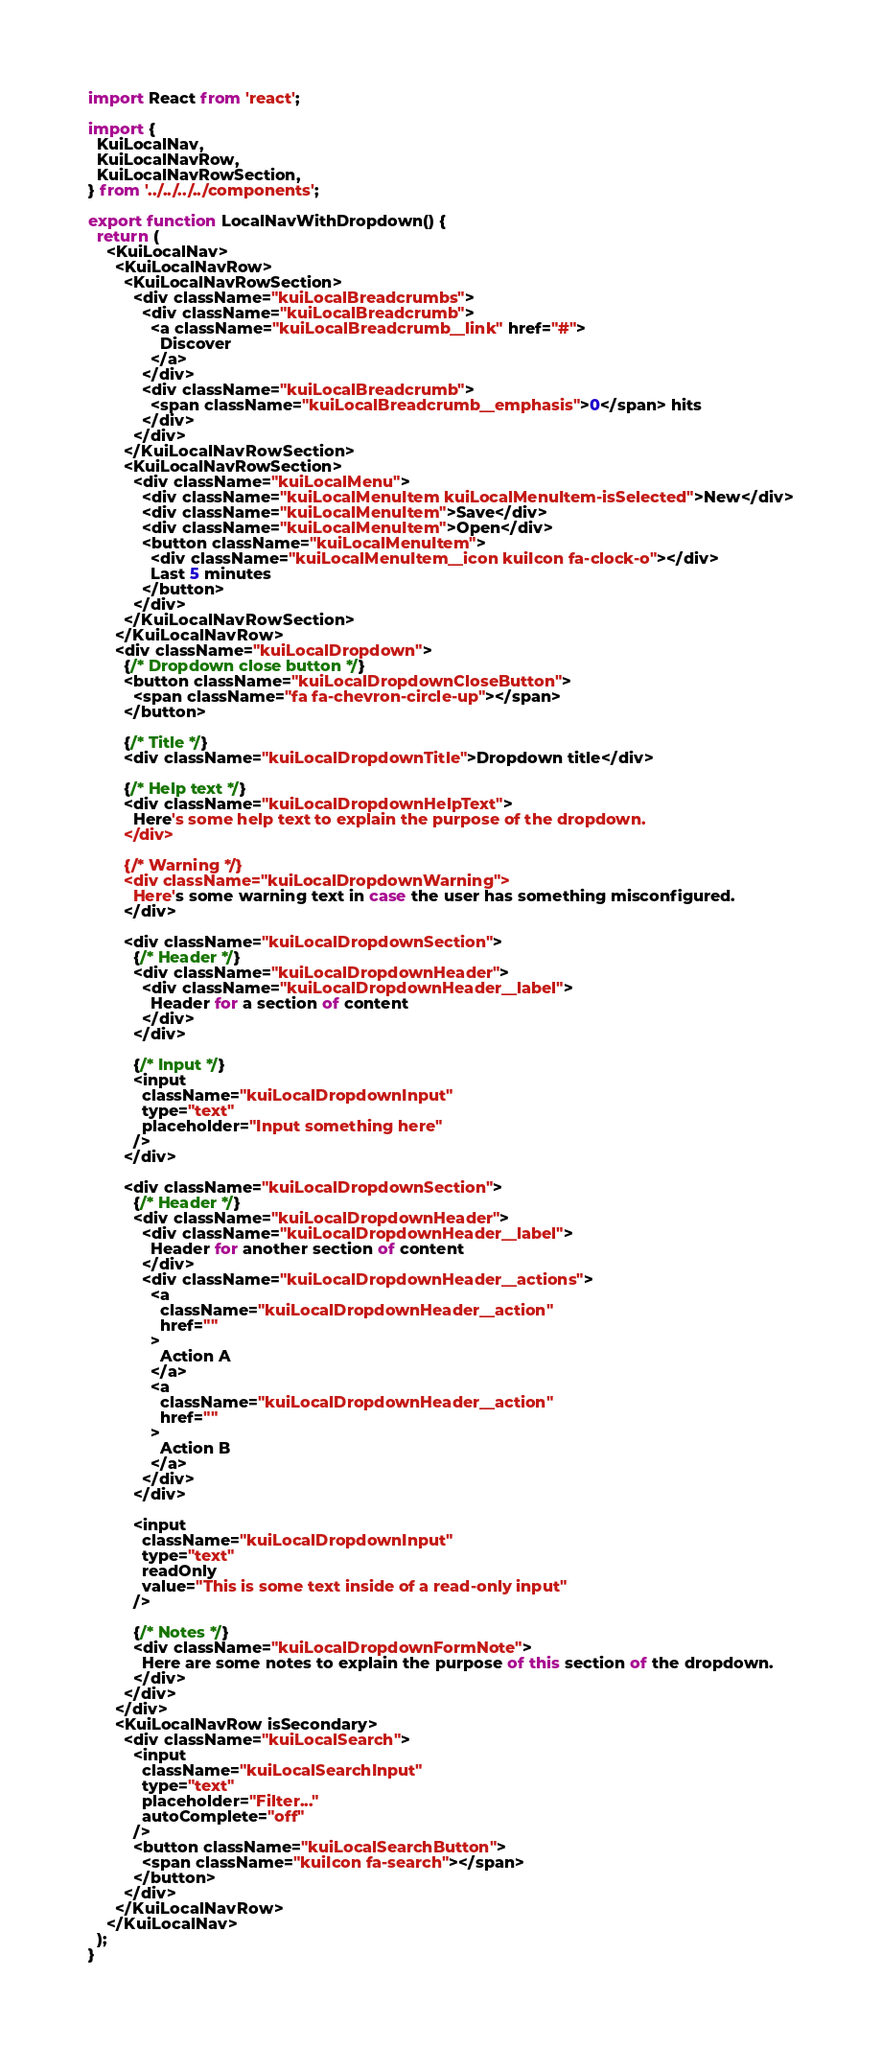Convert code to text. <code><loc_0><loc_0><loc_500><loc_500><_JavaScript_>import React from 'react';

import {
  KuiLocalNav,
  KuiLocalNavRow,
  KuiLocalNavRowSection,
} from '../../../../components';

export function LocalNavWithDropdown() {
  return (
    <KuiLocalNav>
      <KuiLocalNavRow>
        <KuiLocalNavRowSection>
          <div className="kuiLocalBreadcrumbs">
            <div className="kuiLocalBreadcrumb">
              <a className="kuiLocalBreadcrumb__link" href="#">
                Discover
              </a>
            </div>
            <div className="kuiLocalBreadcrumb">
              <span className="kuiLocalBreadcrumb__emphasis">0</span> hits
            </div>
          </div>
        </KuiLocalNavRowSection>
        <KuiLocalNavRowSection>
          <div className="kuiLocalMenu">
            <div className="kuiLocalMenuItem kuiLocalMenuItem-isSelected">New</div>
            <div className="kuiLocalMenuItem">Save</div>
            <div className="kuiLocalMenuItem">Open</div>
            <button className="kuiLocalMenuItem">
              <div className="kuiLocalMenuItem__icon kuiIcon fa-clock-o"></div>
              Last 5 minutes
            </button>
          </div>
        </KuiLocalNavRowSection>
      </KuiLocalNavRow>
      <div className="kuiLocalDropdown">
        {/* Dropdown close button */}
        <button className="kuiLocalDropdownCloseButton">
          <span className="fa fa-chevron-circle-up"></span>
        </button>

        {/* Title */}
        <div className="kuiLocalDropdownTitle">Dropdown title</div>

        {/* Help text */}
        <div className="kuiLocalDropdownHelpText">
          Here's some help text to explain the purpose of the dropdown.
        </div>

        {/* Warning */}
        <div className="kuiLocalDropdownWarning">
          Here's some warning text in case the user has something misconfigured.
        </div>

        <div className="kuiLocalDropdownSection">
          {/* Header */}
          <div className="kuiLocalDropdownHeader">
            <div className="kuiLocalDropdownHeader__label">
              Header for a section of content
            </div>
          </div>

          {/* Input */}
          <input
            className="kuiLocalDropdownInput"
            type="text"
            placeholder="Input something here"
          />
        </div>

        <div className="kuiLocalDropdownSection">
          {/* Header */}
          <div className="kuiLocalDropdownHeader">
            <div className="kuiLocalDropdownHeader__label">
              Header for another section of content
            </div>
            <div className="kuiLocalDropdownHeader__actions">
              <a
                className="kuiLocalDropdownHeader__action"
                href=""
              >
                Action A
              </a>
              <a
                className="kuiLocalDropdownHeader__action"
                href=""
              >
                Action B
              </a>
            </div>
          </div>

          <input
            className="kuiLocalDropdownInput"
            type="text"
            readOnly
            value="This is some text inside of a read-only input"
          />

          {/* Notes */}
          <div className="kuiLocalDropdownFormNote">
            Here are some notes to explain the purpose of this section of the dropdown.
          </div>
        </div>
      </div>
      <KuiLocalNavRow isSecondary>
        <div className="kuiLocalSearch">
          <input
            className="kuiLocalSearchInput"
            type="text"
            placeholder="Filter..."
            autoComplete="off"
          />
          <button className="kuiLocalSearchButton">
            <span className="kuiIcon fa-search"></span>
          </button>
        </div>
      </KuiLocalNavRow>
    </KuiLocalNav>
  );
}
</code> 